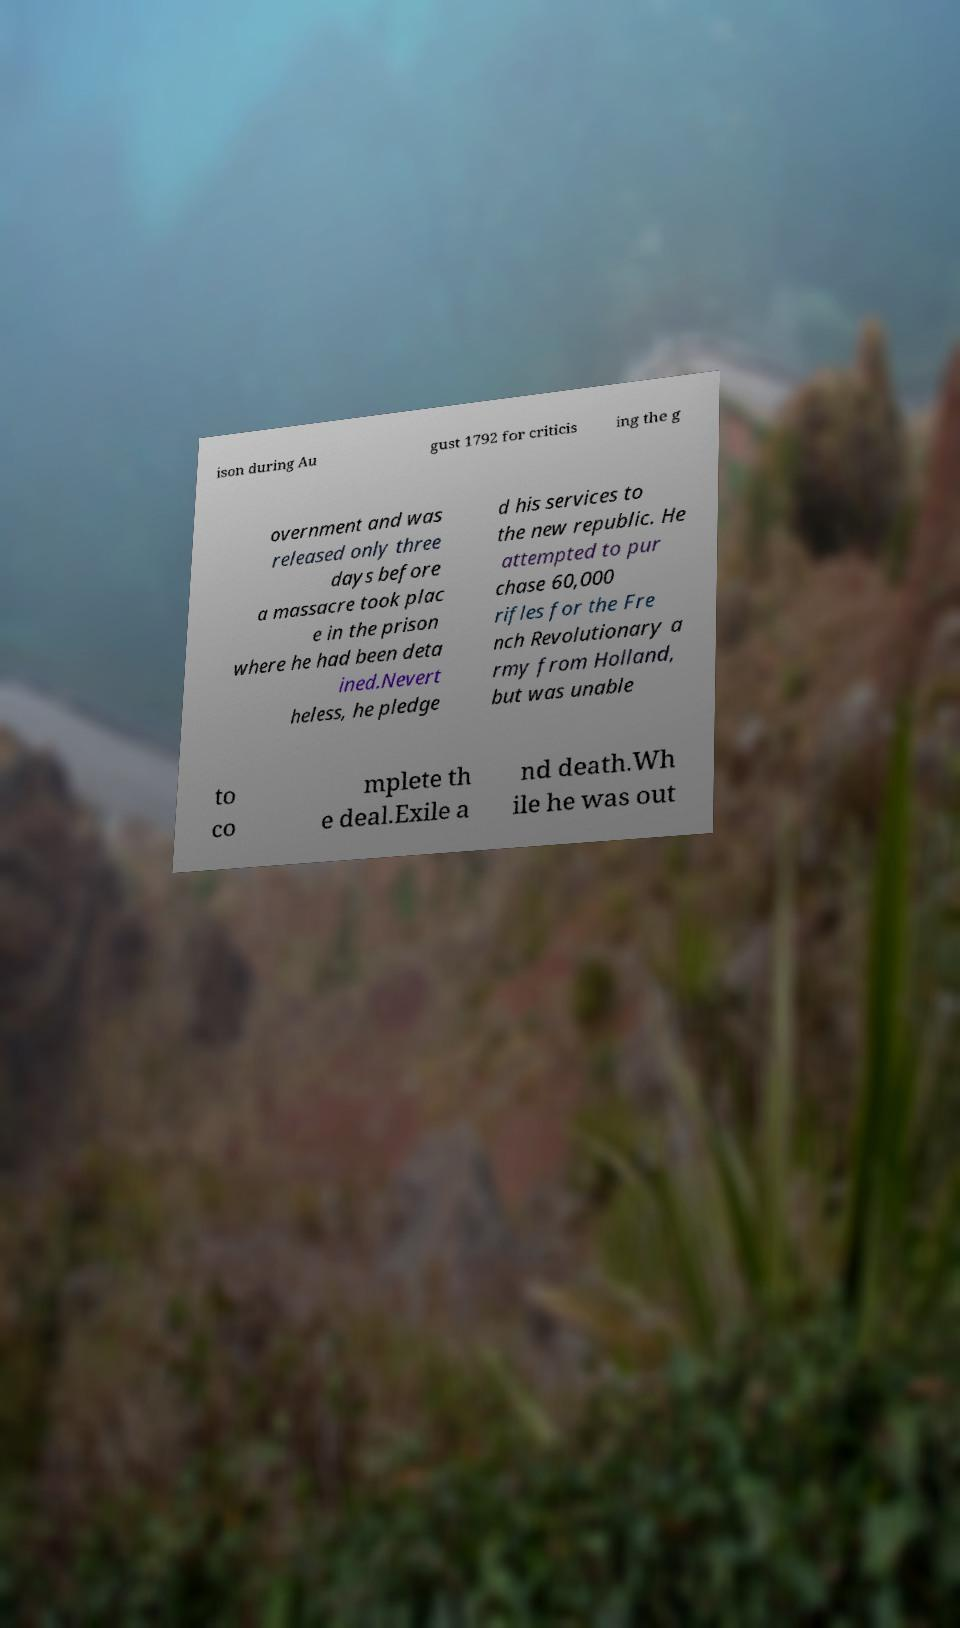For documentation purposes, I need the text within this image transcribed. Could you provide that? ison during Au gust 1792 for criticis ing the g overnment and was released only three days before a massacre took plac e in the prison where he had been deta ined.Nevert heless, he pledge d his services to the new republic. He attempted to pur chase 60,000 rifles for the Fre nch Revolutionary a rmy from Holland, but was unable to co mplete th e deal.Exile a nd death.Wh ile he was out 